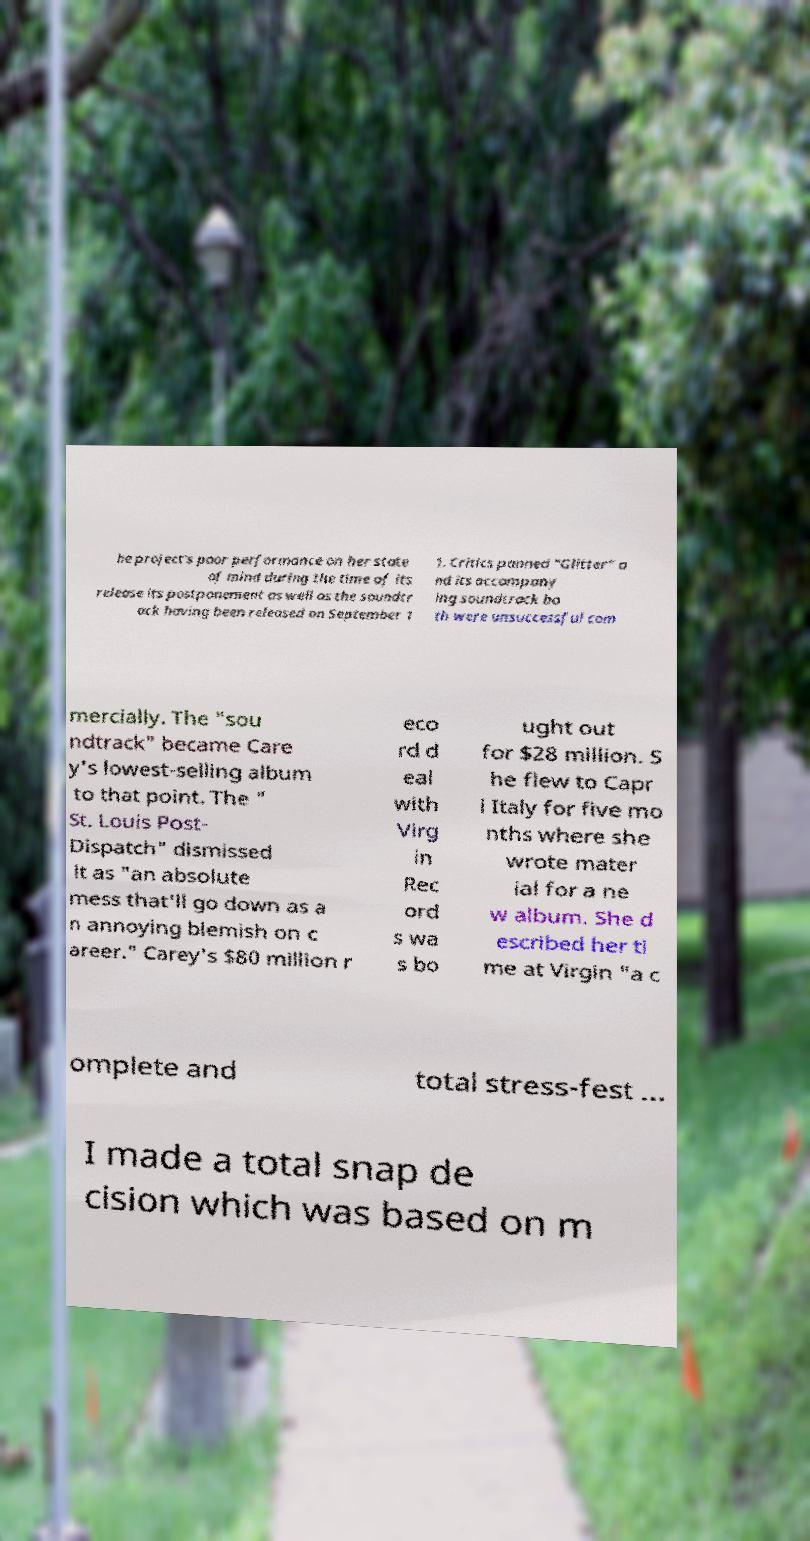Please identify and transcribe the text found in this image. he project's poor performance on her state of mind during the time of its release its postponement as well as the soundtr ack having been released on September 1 1. Critics panned "Glitter" a nd its accompany ing soundtrack bo th were unsuccessful com mercially. The "sou ndtrack" became Care y's lowest-selling album to that point. The " St. Louis Post- Dispatch" dismissed it as "an absolute mess that'll go down as a n annoying blemish on c areer." Carey's $80 million r eco rd d eal with Virg in Rec ord s wa s bo ught out for $28 million. S he flew to Capr i Italy for five mo nths where she wrote mater ial for a ne w album. She d escribed her ti me at Virgin "a c omplete and total stress-fest ... I made a total snap de cision which was based on m 